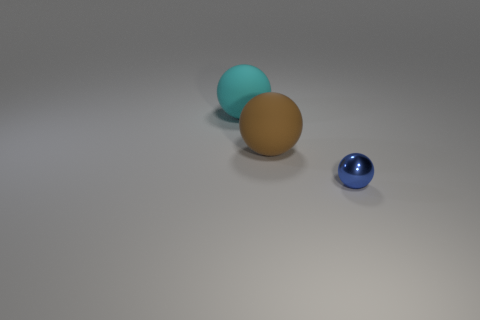Subtract all large matte balls. How many balls are left? 1 Add 3 brown objects. How many objects exist? 6 Add 3 matte balls. How many matte balls are left? 5 Add 2 small brown metal cylinders. How many small brown metal cylinders exist? 2 Subtract 0 brown cubes. How many objects are left? 3 Subtract all large gray metallic objects. Subtract all matte spheres. How many objects are left? 1 